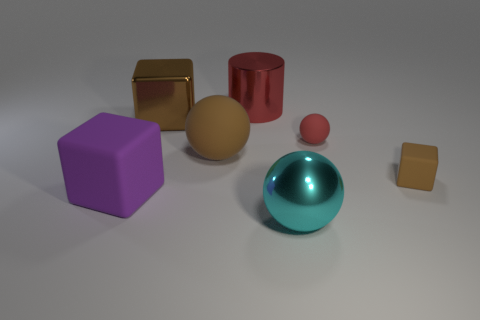There is a cylinder that is behind the cube that is behind the tiny brown matte thing; what number of brown objects are to the right of it?
Your response must be concise. 1. What color is the big metal sphere?
Ensure brevity in your answer.  Cyan. How many other objects are there of the same size as the purple thing?
Keep it short and to the point. 4. There is a purple thing that is the same shape as the small brown object; what is it made of?
Ensure brevity in your answer.  Rubber. There is a large block behind the large rubber thing in front of the matte sphere that is left of the big cyan metallic sphere; what is its material?
Your answer should be very brief. Metal. There is a purple block that is made of the same material as the red sphere; what is its size?
Provide a succinct answer. Large. Is there any other thing of the same color as the large matte ball?
Ensure brevity in your answer.  Yes. Is the color of the metal object that is in front of the brown ball the same as the big matte object that is right of the large purple rubber block?
Your answer should be compact. No. What color is the large matte thing that is in front of the small brown rubber object?
Your response must be concise. Purple. Does the brown block on the left side of the metal ball have the same size as the cyan thing?
Offer a very short reply. Yes. 